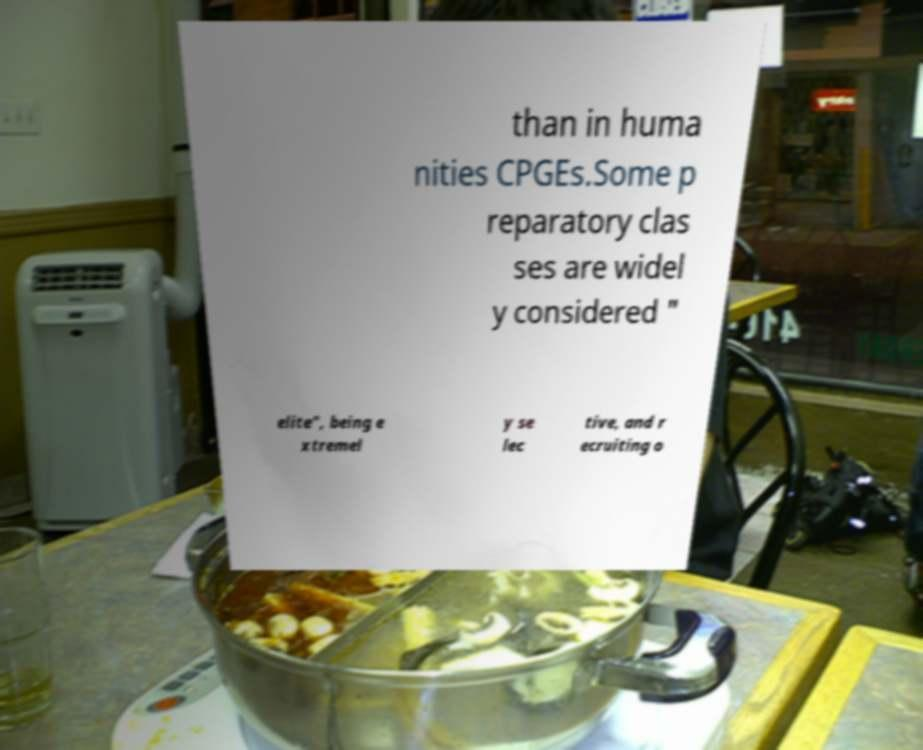Could you assist in decoding the text presented in this image and type it out clearly? than in huma nities CPGEs.Some p reparatory clas ses are widel y considered " elite", being e xtremel y se lec tive, and r ecruiting o 